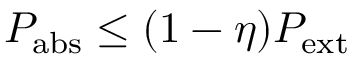Convert formula to latex. <formula><loc_0><loc_0><loc_500><loc_500>P _ { a b s } \leq ( 1 - \eta ) P _ { e x t }</formula> 